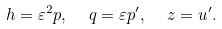<formula> <loc_0><loc_0><loc_500><loc_500>h = \varepsilon ^ { 2 } p , \ \ q = \varepsilon p ^ { \prime } , \ \ z = u ^ { \prime } .</formula> 